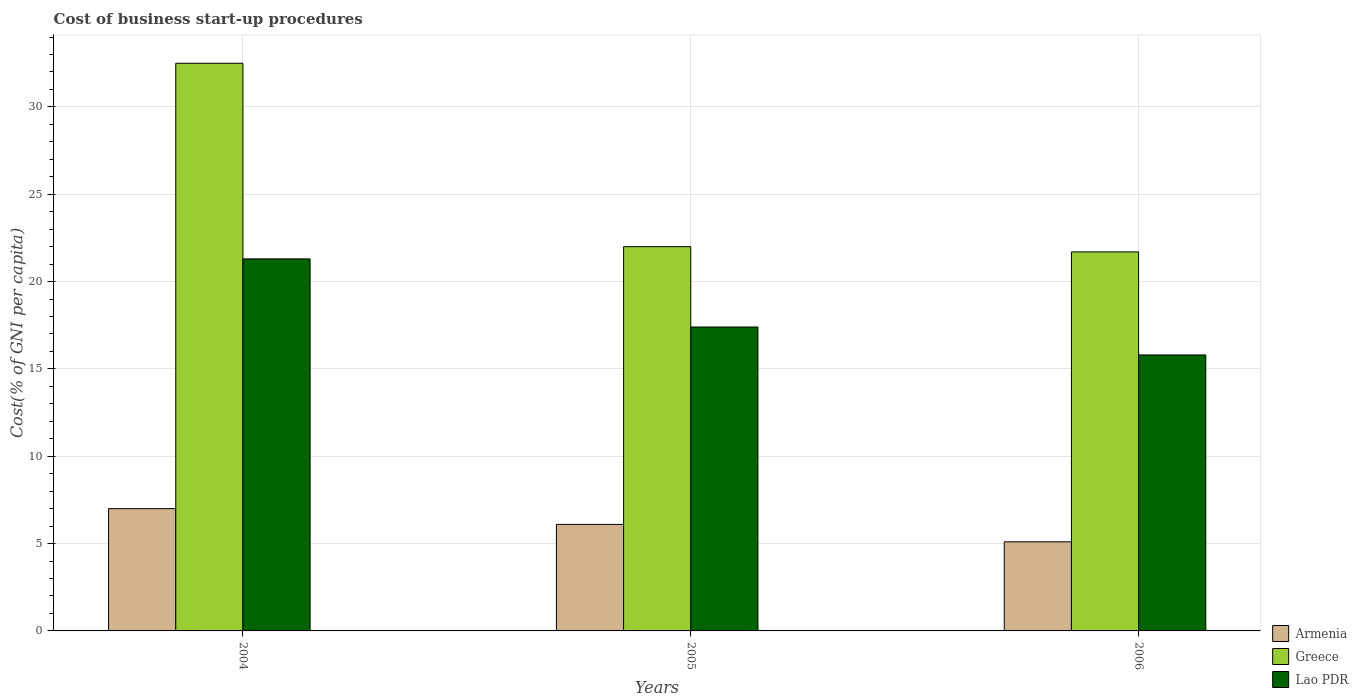How many different coloured bars are there?
Ensure brevity in your answer.  3. How many groups of bars are there?
Your response must be concise. 3. What is the label of the 3rd group of bars from the left?
Your response must be concise. 2006. What is the cost of business start-up procedures in Armenia in 2004?
Your response must be concise. 7. Across all years, what is the maximum cost of business start-up procedures in Lao PDR?
Offer a very short reply. 21.3. Across all years, what is the minimum cost of business start-up procedures in Greece?
Offer a terse response. 21.7. In which year was the cost of business start-up procedures in Greece minimum?
Your answer should be very brief. 2006. What is the total cost of business start-up procedures in Lao PDR in the graph?
Your response must be concise. 54.5. What is the difference between the cost of business start-up procedures in Greece in 2004 and that in 2005?
Provide a short and direct response. 10.5. What is the difference between the cost of business start-up procedures in Lao PDR in 2005 and the cost of business start-up procedures in Greece in 2004?
Give a very brief answer. -15.1. What is the average cost of business start-up procedures in Greece per year?
Your answer should be compact. 25.4. What is the ratio of the cost of business start-up procedures in Greece in 2004 to that in 2006?
Your response must be concise. 1.5. Is the difference between the cost of business start-up procedures in Greece in 2004 and 2005 greater than the difference between the cost of business start-up procedures in Armenia in 2004 and 2005?
Ensure brevity in your answer.  Yes. What is the difference between the highest and the second highest cost of business start-up procedures in Armenia?
Offer a very short reply. 0.9. In how many years, is the cost of business start-up procedures in Armenia greater than the average cost of business start-up procedures in Armenia taken over all years?
Keep it short and to the point. 2. What does the 1st bar from the left in 2004 represents?
Your answer should be compact. Armenia. What does the 3rd bar from the right in 2005 represents?
Ensure brevity in your answer.  Armenia. Are the values on the major ticks of Y-axis written in scientific E-notation?
Give a very brief answer. No. Does the graph contain grids?
Your answer should be compact. Yes. What is the title of the graph?
Your answer should be compact. Cost of business start-up procedures. Does "Pakistan" appear as one of the legend labels in the graph?
Give a very brief answer. No. What is the label or title of the X-axis?
Provide a succinct answer. Years. What is the label or title of the Y-axis?
Your answer should be very brief. Cost(% of GNI per capita). What is the Cost(% of GNI per capita) of Greece in 2004?
Offer a very short reply. 32.5. What is the Cost(% of GNI per capita) in Lao PDR in 2004?
Ensure brevity in your answer.  21.3. What is the Cost(% of GNI per capita) in Armenia in 2005?
Your answer should be very brief. 6.1. What is the Cost(% of GNI per capita) of Greece in 2005?
Provide a short and direct response. 22. What is the Cost(% of GNI per capita) in Greece in 2006?
Ensure brevity in your answer.  21.7. Across all years, what is the maximum Cost(% of GNI per capita) of Greece?
Your response must be concise. 32.5. Across all years, what is the maximum Cost(% of GNI per capita) of Lao PDR?
Ensure brevity in your answer.  21.3. Across all years, what is the minimum Cost(% of GNI per capita) of Armenia?
Your response must be concise. 5.1. Across all years, what is the minimum Cost(% of GNI per capita) in Greece?
Provide a short and direct response. 21.7. Across all years, what is the minimum Cost(% of GNI per capita) of Lao PDR?
Offer a very short reply. 15.8. What is the total Cost(% of GNI per capita) of Armenia in the graph?
Your response must be concise. 18.2. What is the total Cost(% of GNI per capita) of Greece in the graph?
Make the answer very short. 76.2. What is the total Cost(% of GNI per capita) of Lao PDR in the graph?
Make the answer very short. 54.5. What is the difference between the Cost(% of GNI per capita) in Armenia in 2004 and that in 2005?
Provide a short and direct response. 0.9. What is the difference between the Cost(% of GNI per capita) in Greece in 2004 and that in 2005?
Offer a terse response. 10.5. What is the difference between the Cost(% of GNI per capita) of Lao PDR in 2004 and that in 2005?
Ensure brevity in your answer.  3.9. What is the difference between the Cost(% of GNI per capita) in Armenia in 2004 and that in 2006?
Provide a short and direct response. 1.9. What is the difference between the Cost(% of GNI per capita) in Greece in 2004 and that in 2006?
Keep it short and to the point. 10.8. What is the difference between the Cost(% of GNI per capita) in Armenia in 2005 and that in 2006?
Give a very brief answer. 1. What is the difference between the Cost(% of GNI per capita) in Greece in 2005 and that in 2006?
Your answer should be compact. 0.3. What is the difference between the Cost(% of GNI per capita) of Greece in 2004 and the Cost(% of GNI per capita) of Lao PDR in 2005?
Ensure brevity in your answer.  15.1. What is the difference between the Cost(% of GNI per capita) of Armenia in 2004 and the Cost(% of GNI per capita) of Greece in 2006?
Provide a short and direct response. -14.7. What is the difference between the Cost(% of GNI per capita) of Armenia in 2004 and the Cost(% of GNI per capita) of Lao PDR in 2006?
Offer a very short reply. -8.8. What is the difference between the Cost(% of GNI per capita) in Armenia in 2005 and the Cost(% of GNI per capita) in Greece in 2006?
Offer a very short reply. -15.6. What is the difference between the Cost(% of GNI per capita) of Armenia in 2005 and the Cost(% of GNI per capita) of Lao PDR in 2006?
Make the answer very short. -9.7. What is the difference between the Cost(% of GNI per capita) of Greece in 2005 and the Cost(% of GNI per capita) of Lao PDR in 2006?
Offer a terse response. 6.2. What is the average Cost(% of GNI per capita) of Armenia per year?
Offer a very short reply. 6.07. What is the average Cost(% of GNI per capita) in Greece per year?
Provide a short and direct response. 25.4. What is the average Cost(% of GNI per capita) in Lao PDR per year?
Offer a very short reply. 18.17. In the year 2004, what is the difference between the Cost(% of GNI per capita) in Armenia and Cost(% of GNI per capita) in Greece?
Make the answer very short. -25.5. In the year 2004, what is the difference between the Cost(% of GNI per capita) of Armenia and Cost(% of GNI per capita) of Lao PDR?
Your response must be concise. -14.3. In the year 2004, what is the difference between the Cost(% of GNI per capita) of Greece and Cost(% of GNI per capita) of Lao PDR?
Ensure brevity in your answer.  11.2. In the year 2005, what is the difference between the Cost(% of GNI per capita) of Armenia and Cost(% of GNI per capita) of Greece?
Make the answer very short. -15.9. In the year 2005, what is the difference between the Cost(% of GNI per capita) in Armenia and Cost(% of GNI per capita) in Lao PDR?
Your answer should be compact. -11.3. In the year 2005, what is the difference between the Cost(% of GNI per capita) in Greece and Cost(% of GNI per capita) in Lao PDR?
Provide a succinct answer. 4.6. In the year 2006, what is the difference between the Cost(% of GNI per capita) in Armenia and Cost(% of GNI per capita) in Greece?
Make the answer very short. -16.6. In the year 2006, what is the difference between the Cost(% of GNI per capita) of Armenia and Cost(% of GNI per capita) of Lao PDR?
Ensure brevity in your answer.  -10.7. What is the ratio of the Cost(% of GNI per capita) in Armenia in 2004 to that in 2005?
Offer a very short reply. 1.15. What is the ratio of the Cost(% of GNI per capita) in Greece in 2004 to that in 2005?
Give a very brief answer. 1.48. What is the ratio of the Cost(% of GNI per capita) of Lao PDR in 2004 to that in 2005?
Give a very brief answer. 1.22. What is the ratio of the Cost(% of GNI per capita) of Armenia in 2004 to that in 2006?
Make the answer very short. 1.37. What is the ratio of the Cost(% of GNI per capita) in Greece in 2004 to that in 2006?
Your response must be concise. 1.5. What is the ratio of the Cost(% of GNI per capita) of Lao PDR in 2004 to that in 2006?
Offer a terse response. 1.35. What is the ratio of the Cost(% of GNI per capita) of Armenia in 2005 to that in 2006?
Your response must be concise. 1.2. What is the ratio of the Cost(% of GNI per capita) in Greece in 2005 to that in 2006?
Offer a terse response. 1.01. What is the ratio of the Cost(% of GNI per capita) in Lao PDR in 2005 to that in 2006?
Provide a short and direct response. 1.1. What is the difference between the highest and the second highest Cost(% of GNI per capita) of Armenia?
Give a very brief answer. 0.9. What is the difference between the highest and the second highest Cost(% of GNI per capita) in Lao PDR?
Ensure brevity in your answer.  3.9. What is the difference between the highest and the lowest Cost(% of GNI per capita) in Armenia?
Your answer should be compact. 1.9. What is the difference between the highest and the lowest Cost(% of GNI per capita) in Greece?
Your answer should be compact. 10.8. What is the difference between the highest and the lowest Cost(% of GNI per capita) of Lao PDR?
Offer a terse response. 5.5. 